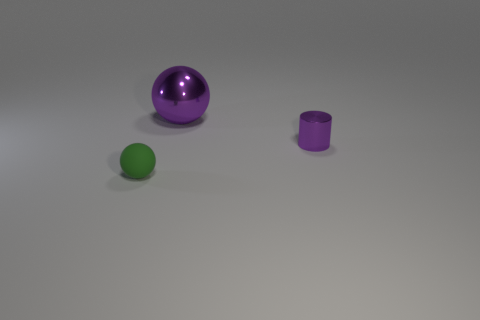There is a shiny thing to the right of the big metal ball; does it have the same color as the thing behind the shiny cylinder?
Give a very brief answer. Yes. The small purple object that is made of the same material as the purple ball is what shape?
Your answer should be compact. Cylinder. Is there anything else that is the same shape as the tiny purple shiny thing?
Your answer should be very brief. No. What number of green matte objects have the same size as the purple sphere?
Ensure brevity in your answer.  0. The sphere that is the same color as the tiny shiny object is what size?
Your answer should be very brief. Large. Does the tiny matte ball have the same color as the shiny cylinder?
Keep it short and to the point. No. There is a small green object; what shape is it?
Your answer should be compact. Sphere. Are there any other metal objects that have the same color as the small metal thing?
Offer a terse response. Yes. Are there more big purple metallic spheres that are left of the small green object than purple matte objects?
Keep it short and to the point. No. There is a tiny purple metal object; does it have the same shape as the tiny thing that is left of the large object?
Provide a succinct answer. No. 